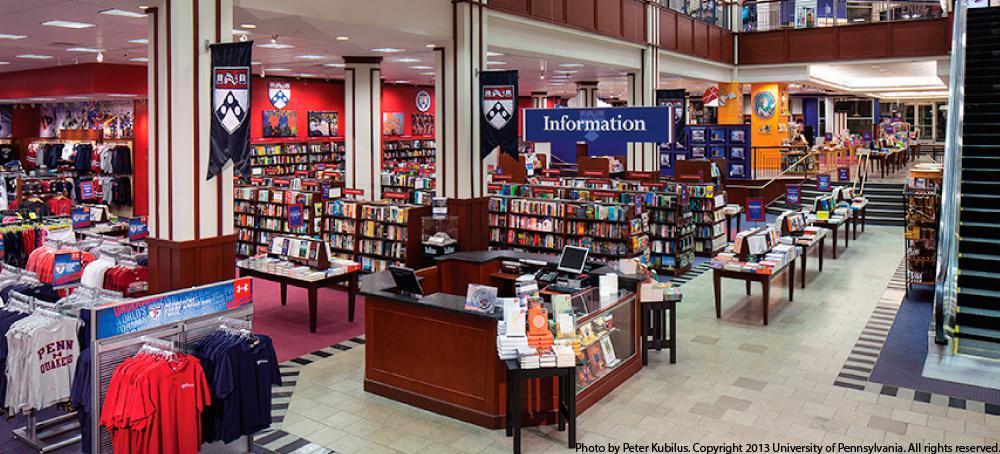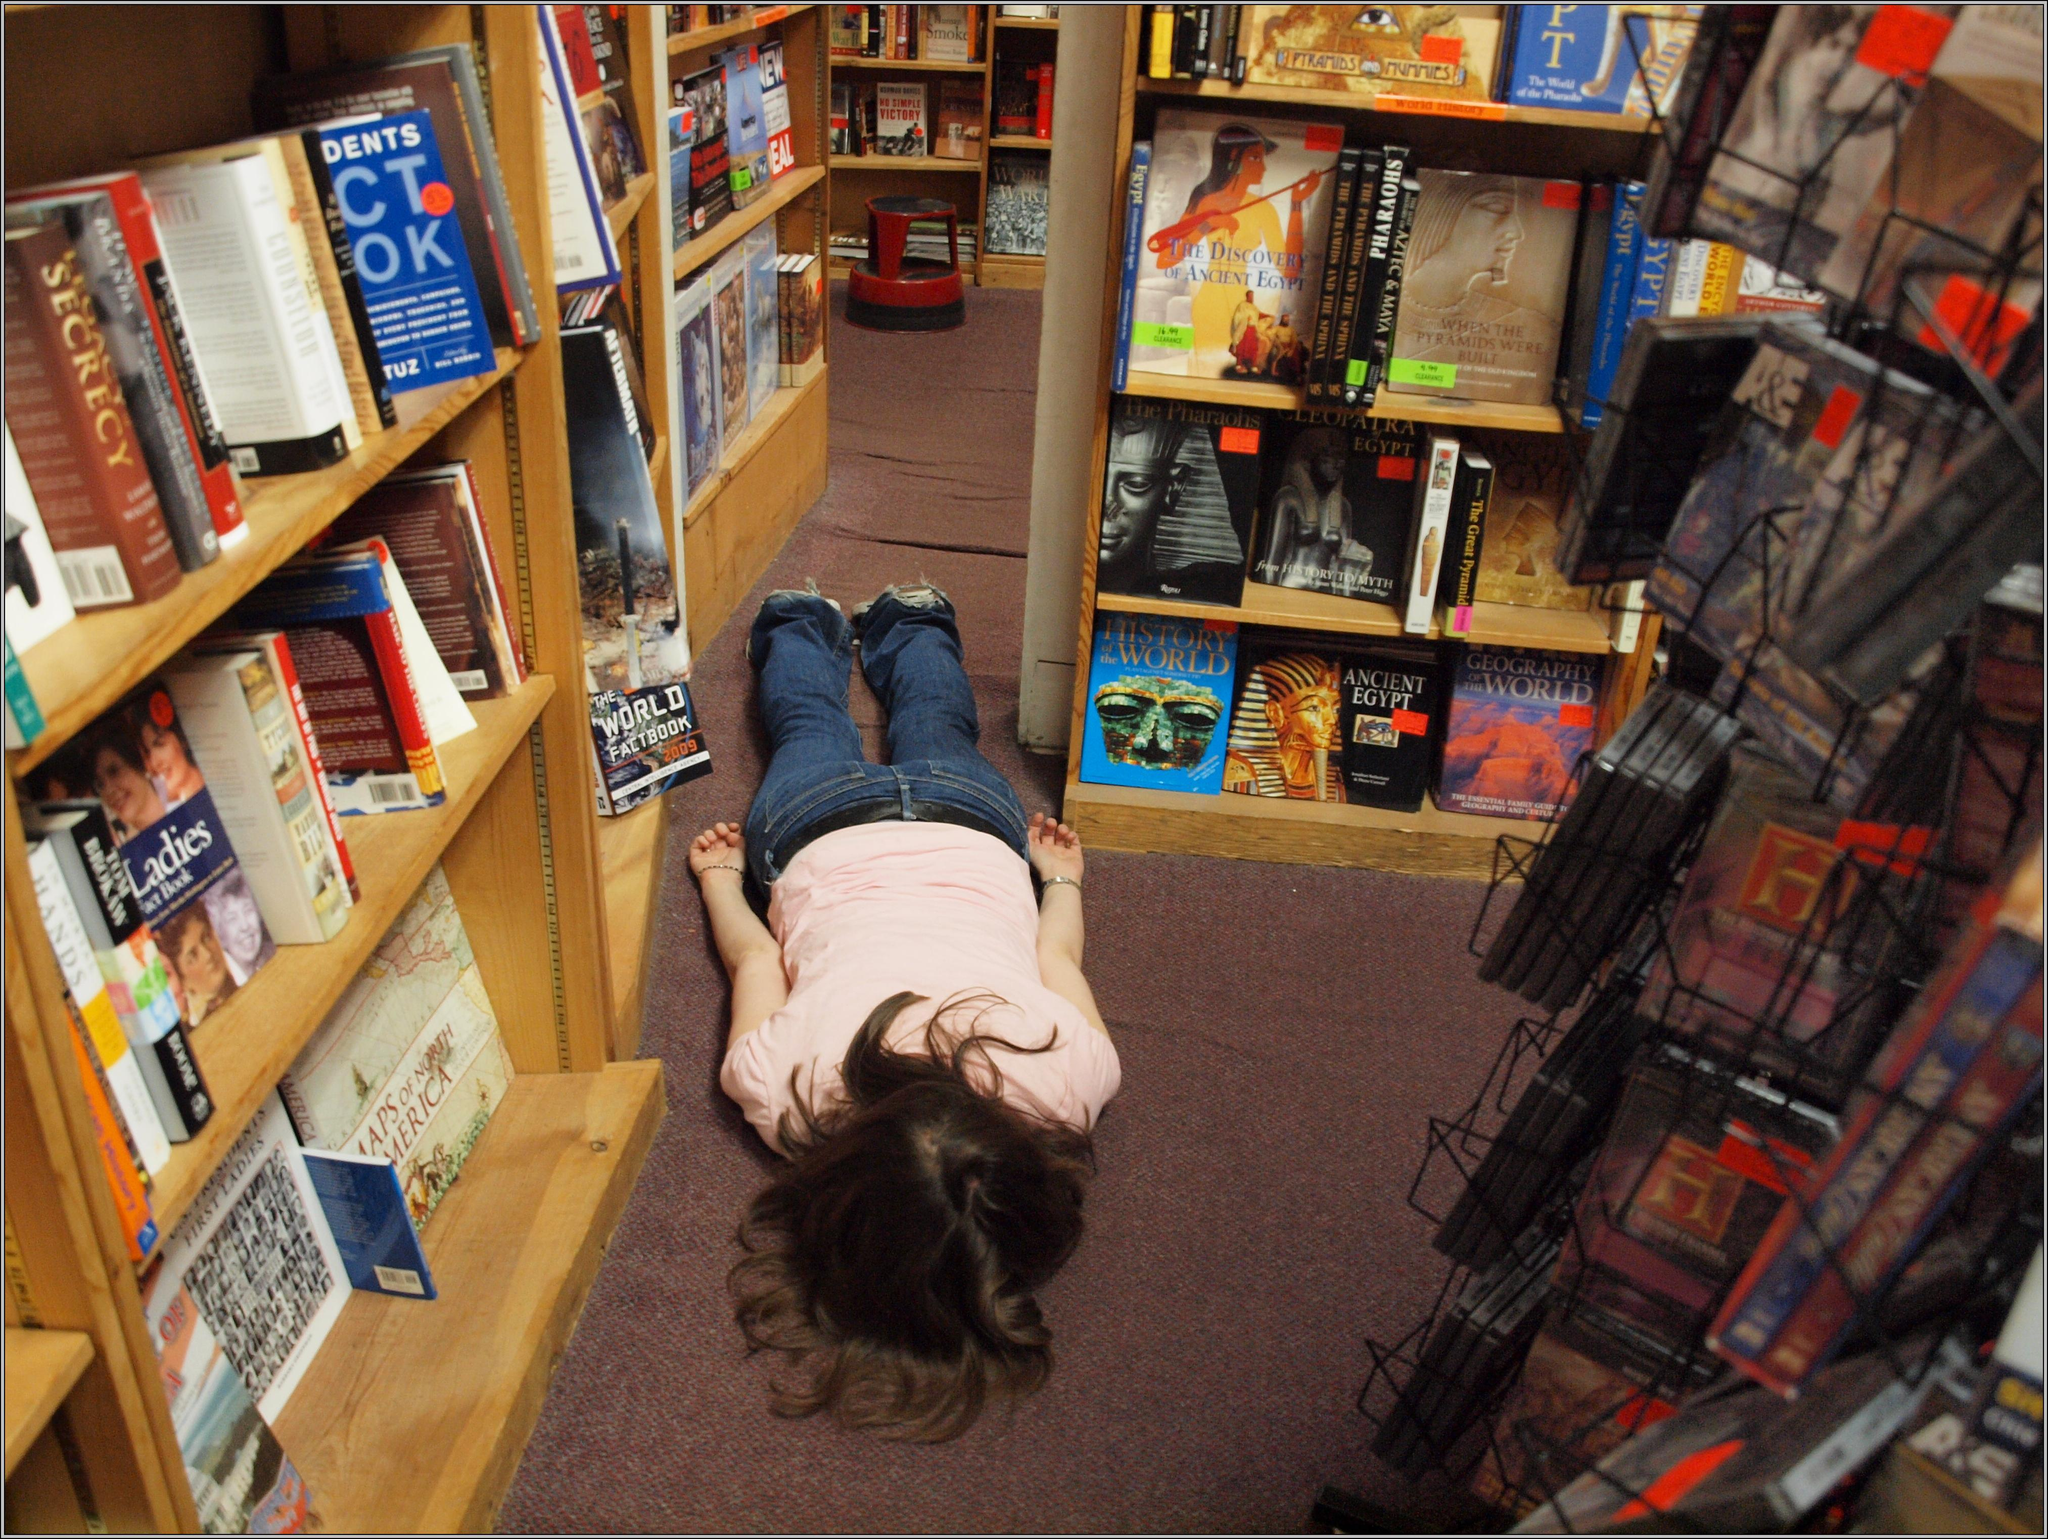The first image is the image on the left, the second image is the image on the right. Analyze the images presented: Is the assertion "Someone is standing while reading a book." valid? Answer yes or no. No. The first image is the image on the left, the second image is the image on the right. Assess this claim about the two images: "There is exactly one person.". Correct or not? Answer yes or no. Yes. 